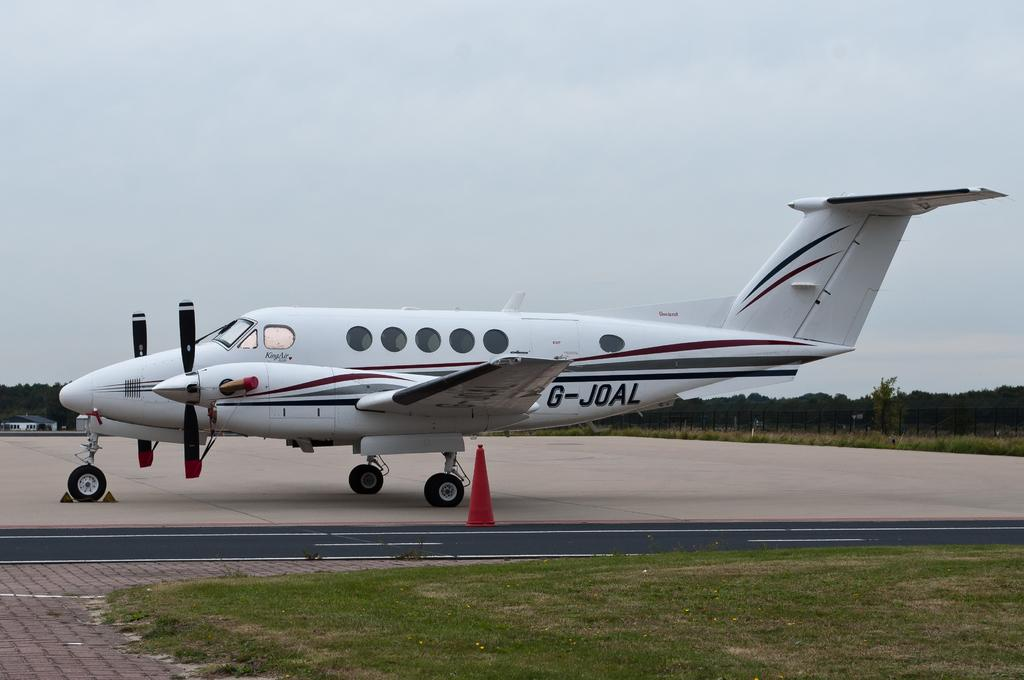<image>
Relay a brief, clear account of the picture shown. a small propeller plane with G-JOAL on the side parked on a runway 